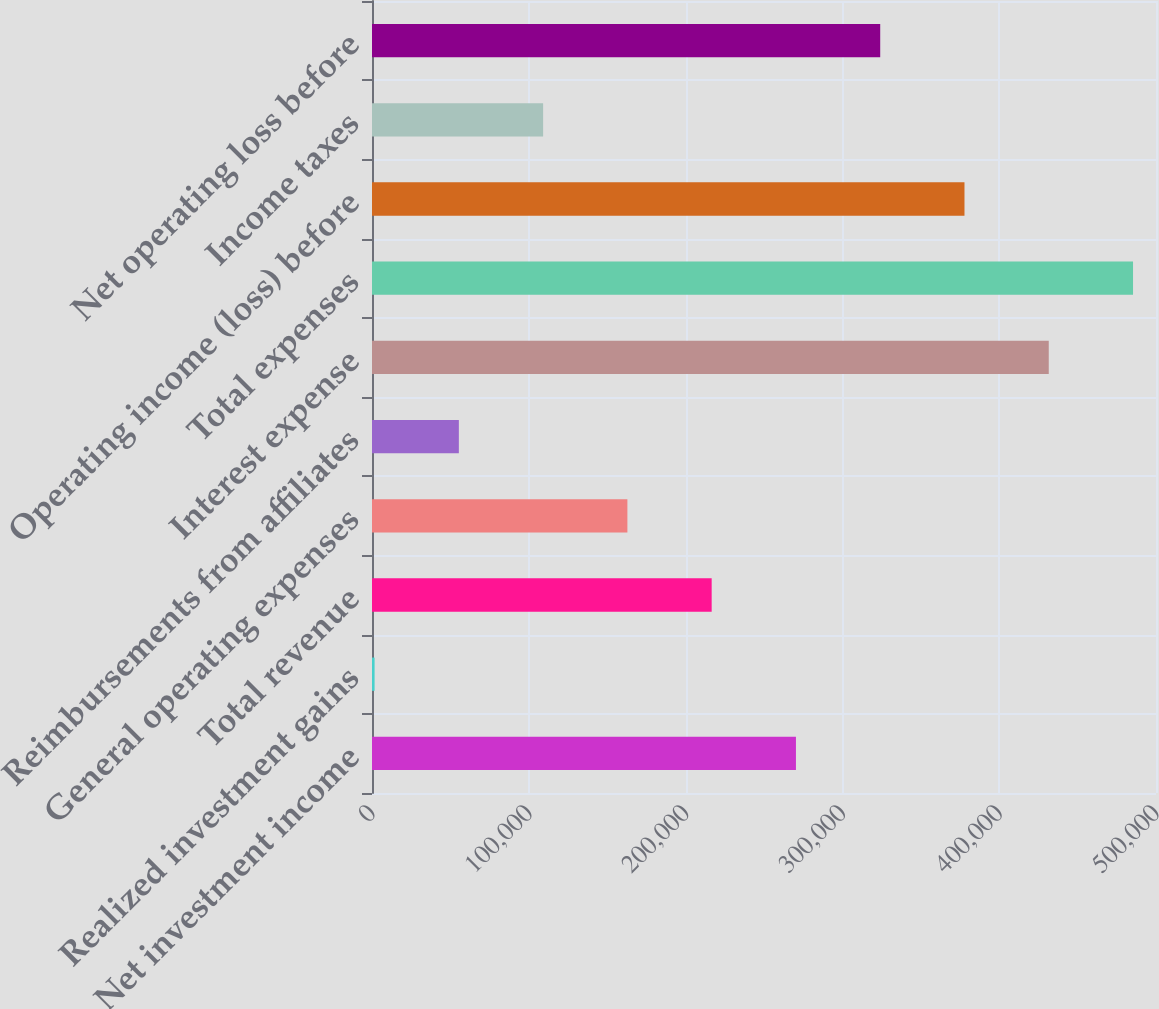<chart> <loc_0><loc_0><loc_500><loc_500><bar_chart><fcel>Net investment income<fcel>Realized investment gains<fcel>Total revenue<fcel>General operating expenses<fcel>Reimbursements from affiliates<fcel>Interest expense<fcel>Total expenses<fcel>Operating income (loss) before<fcel>Income taxes<fcel>Net operating loss before<nl><fcel>270370<fcel>1646<fcel>216625<fcel>162880<fcel>55390.8<fcel>431604<fcel>485349<fcel>377860<fcel>109136<fcel>324115<nl></chart> 